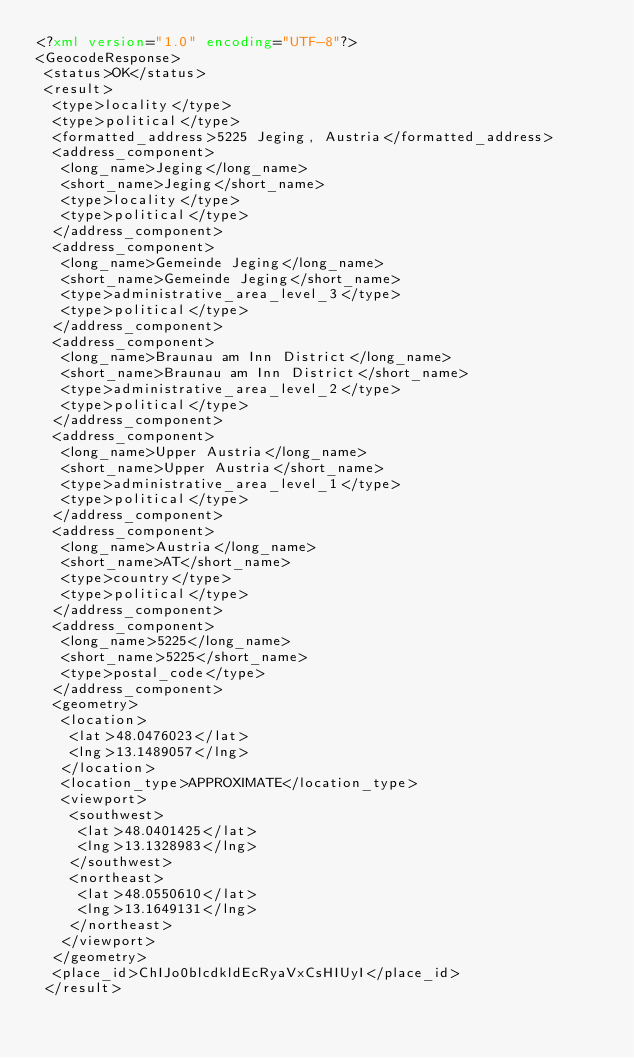<code> <loc_0><loc_0><loc_500><loc_500><_XML_><?xml version="1.0" encoding="UTF-8"?>
<GeocodeResponse>
 <status>OK</status>
 <result>
  <type>locality</type>
  <type>political</type>
  <formatted_address>5225 Jeging, Austria</formatted_address>
  <address_component>
   <long_name>Jeging</long_name>
   <short_name>Jeging</short_name>
   <type>locality</type>
   <type>political</type>
  </address_component>
  <address_component>
   <long_name>Gemeinde Jeging</long_name>
   <short_name>Gemeinde Jeging</short_name>
   <type>administrative_area_level_3</type>
   <type>political</type>
  </address_component>
  <address_component>
   <long_name>Braunau am Inn District</long_name>
   <short_name>Braunau am Inn District</short_name>
   <type>administrative_area_level_2</type>
   <type>political</type>
  </address_component>
  <address_component>
   <long_name>Upper Austria</long_name>
   <short_name>Upper Austria</short_name>
   <type>administrative_area_level_1</type>
   <type>political</type>
  </address_component>
  <address_component>
   <long_name>Austria</long_name>
   <short_name>AT</short_name>
   <type>country</type>
   <type>political</type>
  </address_component>
  <address_component>
   <long_name>5225</long_name>
   <short_name>5225</short_name>
   <type>postal_code</type>
  </address_component>
  <geometry>
   <location>
    <lat>48.0476023</lat>
    <lng>13.1489057</lng>
   </location>
   <location_type>APPROXIMATE</location_type>
   <viewport>
    <southwest>
     <lat>48.0401425</lat>
     <lng>13.1328983</lng>
    </southwest>
    <northeast>
     <lat>48.0550610</lat>
     <lng>13.1649131</lng>
    </northeast>
   </viewport>
  </geometry>
  <place_id>ChIJo0blcdkldEcRyaVxCsHIUyI</place_id>
 </result></code> 